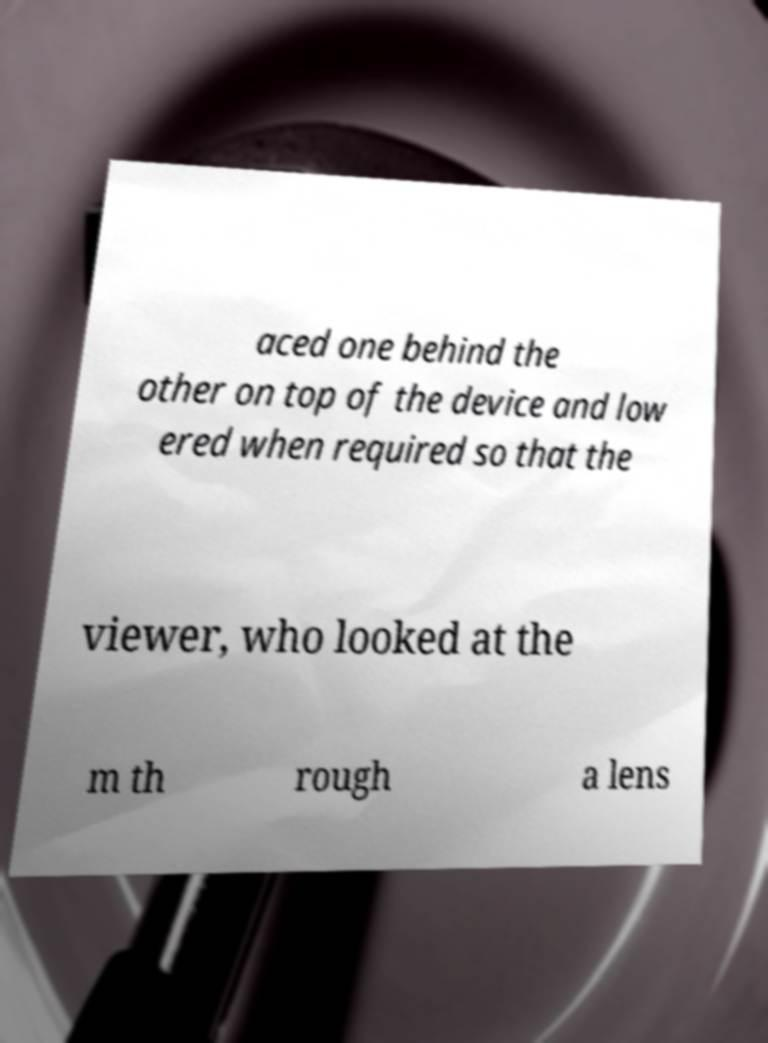For documentation purposes, I need the text within this image transcribed. Could you provide that? aced one behind the other on top of the device and low ered when required so that the viewer, who looked at the m th rough a lens 